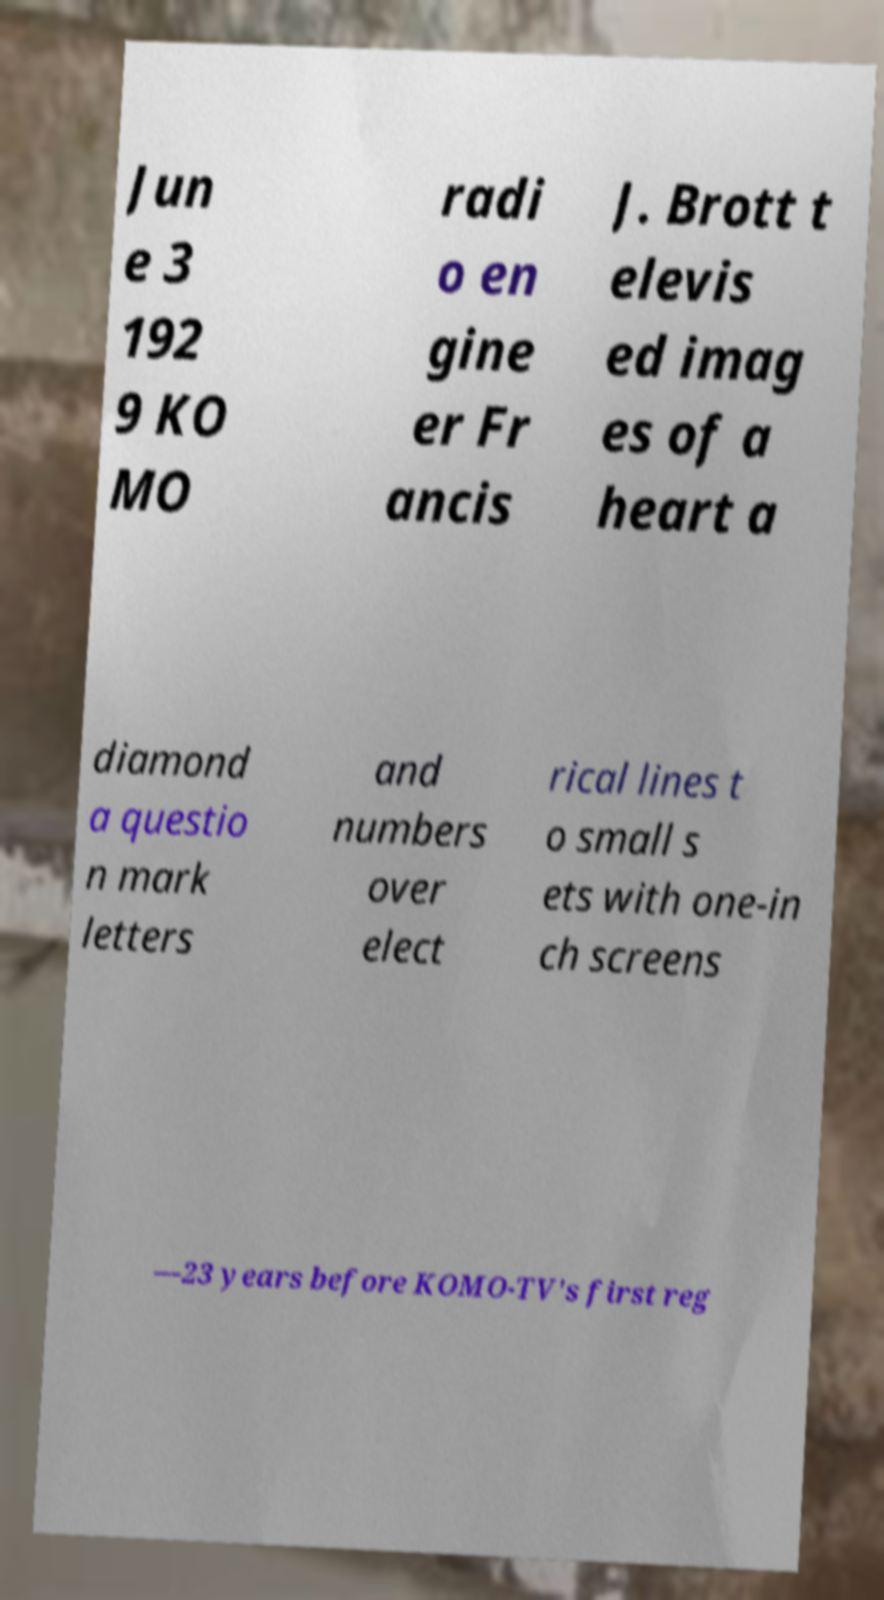There's text embedded in this image that I need extracted. Can you transcribe it verbatim? Jun e 3 192 9 KO MO radi o en gine er Fr ancis J. Brott t elevis ed imag es of a heart a diamond a questio n mark letters and numbers over elect rical lines t o small s ets with one-in ch screens —23 years before KOMO-TV's first reg 